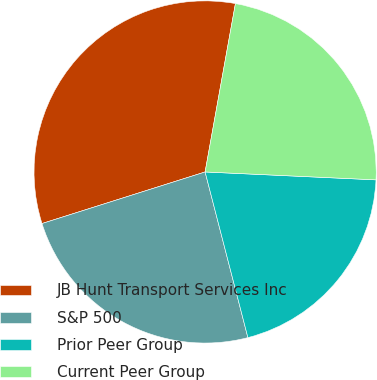<chart> <loc_0><loc_0><loc_500><loc_500><pie_chart><fcel>JB Hunt Transport Services Inc<fcel>S&P 500<fcel>Prior Peer Group<fcel>Current Peer Group<nl><fcel>32.71%<fcel>24.15%<fcel>20.24%<fcel>22.9%<nl></chart> 